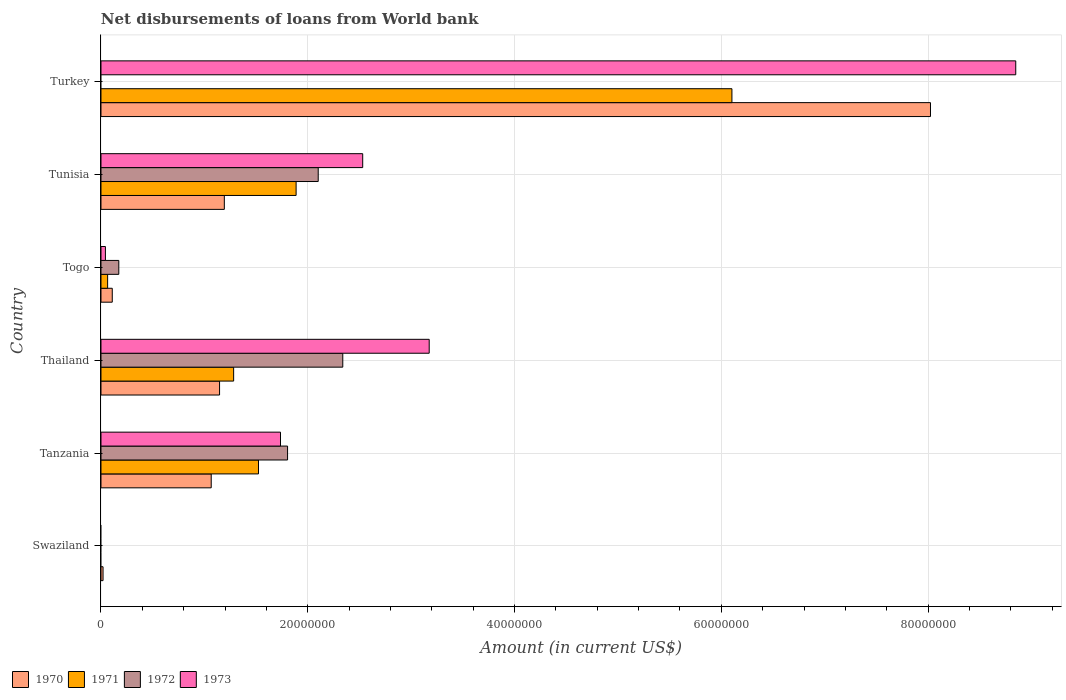Are the number of bars on each tick of the Y-axis equal?
Your response must be concise. No. What is the label of the 1st group of bars from the top?
Give a very brief answer. Turkey. In how many cases, is the number of bars for a given country not equal to the number of legend labels?
Keep it short and to the point. 2. What is the amount of loan disbursed from World Bank in 1973 in Tanzania?
Ensure brevity in your answer.  1.74e+07. Across all countries, what is the maximum amount of loan disbursed from World Bank in 1973?
Provide a succinct answer. 8.85e+07. What is the total amount of loan disbursed from World Bank in 1970 in the graph?
Provide a short and direct response. 1.16e+08. What is the difference between the amount of loan disbursed from World Bank in 1973 in Togo and that in Tunisia?
Make the answer very short. -2.49e+07. What is the difference between the amount of loan disbursed from World Bank in 1972 in Tunisia and the amount of loan disbursed from World Bank in 1970 in Tanzania?
Provide a succinct answer. 1.04e+07. What is the average amount of loan disbursed from World Bank in 1970 per country?
Your response must be concise. 1.93e+07. What is the difference between the amount of loan disbursed from World Bank in 1972 and amount of loan disbursed from World Bank in 1971 in Togo?
Offer a very short reply. 1.08e+06. What is the ratio of the amount of loan disbursed from World Bank in 1970 in Thailand to that in Togo?
Provide a short and direct response. 10.51. Is the amount of loan disbursed from World Bank in 1972 in Tanzania less than that in Thailand?
Give a very brief answer. Yes. What is the difference between the highest and the second highest amount of loan disbursed from World Bank in 1970?
Your answer should be compact. 6.83e+07. What is the difference between the highest and the lowest amount of loan disbursed from World Bank in 1972?
Ensure brevity in your answer.  2.34e+07. In how many countries, is the amount of loan disbursed from World Bank in 1973 greater than the average amount of loan disbursed from World Bank in 1973 taken over all countries?
Keep it short and to the point. 2. Is the sum of the amount of loan disbursed from World Bank in 1970 in Tanzania and Thailand greater than the maximum amount of loan disbursed from World Bank in 1972 across all countries?
Offer a terse response. No. Is it the case that in every country, the sum of the amount of loan disbursed from World Bank in 1972 and amount of loan disbursed from World Bank in 1973 is greater than the amount of loan disbursed from World Bank in 1970?
Make the answer very short. No. How many countries are there in the graph?
Offer a terse response. 6. Does the graph contain grids?
Your response must be concise. Yes. How are the legend labels stacked?
Your response must be concise. Horizontal. What is the title of the graph?
Your answer should be compact. Net disbursements of loans from World bank. Does "1976" appear as one of the legend labels in the graph?
Give a very brief answer. No. What is the Amount (in current US$) of 1970 in Swaziland?
Give a very brief answer. 1.99e+05. What is the Amount (in current US$) in 1972 in Swaziland?
Ensure brevity in your answer.  0. What is the Amount (in current US$) of 1970 in Tanzania?
Your answer should be compact. 1.07e+07. What is the Amount (in current US$) in 1971 in Tanzania?
Ensure brevity in your answer.  1.52e+07. What is the Amount (in current US$) in 1972 in Tanzania?
Offer a terse response. 1.80e+07. What is the Amount (in current US$) of 1973 in Tanzania?
Provide a short and direct response. 1.74e+07. What is the Amount (in current US$) of 1970 in Thailand?
Make the answer very short. 1.15e+07. What is the Amount (in current US$) of 1971 in Thailand?
Ensure brevity in your answer.  1.28e+07. What is the Amount (in current US$) of 1972 in Thailand?
Give a very brief answer. 2.34e+07. What is the Amount (in current US$) of 1973 in Thailand?
Your response must be concise. 3.17e+07. What is the Amount (in current US$) of 1970 in Togo?
Offer a terse response. 1.09e+06. What is the Amount (in current US$) in 1971 in Togo?
Your response must be concise. 6.42e+05. What is the Amount (in current US$) of 1972 in Togo?
Provide a succinct answer. 1.72e+06. What is the Amount (in current US$) in 1973 in Togo?
Your response must be concise. 4.29e+05. What is the Amount (in current US$) of 1970 in Tunisia?
Your answer should be compact. 1.19e+07. What is the Amount (in current US$) in 1971 in Tunisia?
Your answer should be compact. 1.89e+07. What is the Amount (in current US$) of 1972 in Tunisia?
Your response must be concise. 2.10e+07. What is the Amount (in current US$) in 1973 in Tunisia?
Offer a terse response. 2.53e+07. What is the Amount (in current US$) in 1970 in Turkey?
Your response must be concise. 8.02e+07. What is the Amount (in current US$) in 1971 in Turkey?
Offer a very short reply. 6.10e+07. What is the Amount (in current US$) of 1973 in Turkey?
Offer a very short reply. 8.85e+07. Across all countries, what is the maximum Amount (in current US$) in 1970?
Your answer should be compact. 8.02e+07. Across all countries, what is the maximum Amount (in current US$) in 1971?
Keep it short and to the point. 6.10e+07. Across all countries, what is the maximum Amount (in current US$) in 1972?
Provide a succinct answer. 2.34e+07. Across all countries, what is the maximum Amount (in current US$) of 1973?
Your response must be concise. 8.85e+07. Across all countries, what is the minimum Amount (in current US$) in 1970?
Keep it short and to the point. 1.99e+05. Across all countries, what is the minimum Amount (in current US$) of 1971?
Keep it short and to the point. 0. What is the total Amount (in current US$) of 1970 in the graph?
Your response must be concise. 1.16e+08. What is the total Amount (in current US$) in 1971 in the graph?
Provide a succinct answer. 1.09e+08. What is the total Amount (in current US$) of 1972 in the graph?
Ensure brevity in your answer.  6.42e+07. What is the total Amount (in current US$) in 1973 in the graph?
Provide a short and direct response. 1.63e+08. What is the difference between the Amount (in current US$) in 1970 in Swaziland and that in Tanzania?
Offer a very short reply. -1.05e+07. What is the difference between the Amount (in current US$) in 1970 in Swaziland and that in Thailand?
Give a very brief answer. -1.13e+07. What is the difference between the Amount (in current US$) of 1970 in Swaziland and that in Togo?
Ensure brevity in your answer.  -8.92e+05. What is the difference between the Amount (in current US$) in 1970 in Swaziland and that in Tunisia?
Give a very brief answer. -1.17e+07. What is the difference between the Amount (in current US$) of 1970 in Swaziland and that in Turkey?
Provide a short and direct response. -8.00e+07. What is the difference between the Amount (in current US$) in 1970 in Tanzania and that in Thailand?
Ensure brevity in your answer.  -8.08e+05. What is the difference between the Amount (in current US$) in 1971 in Tanzania and that in Thailand?
Your response must be concise. 2.40e+06. What is the difference between the Amount (in current US$) in 1972 in Tanzania and that in Thailand?
Provide a succinct answer. -5.34e+06. What is the difference between the Amount (in current US$) of 1973 in Tanzania and that in Thailand?
Ensure brevity in your answer.  -1.44e+07. What is the difference between the Amount (in current US$) in 1970 in Tanzania and that in Togo?
Your response must be concise. 9.57e+06. What is the difference between the Amount (in current US$) of 1971 in Tanzania and that in Togo?
Make the answer very short. 1.46e+07. What is the difference between the Amount (in current US$) of 1972 in Tanzania and that in Togo?
Offer a terse response. 1.63e+07. What is the difference between the Amount (in current US$) in 1973 in Tanzania and that in Togo?
Your answer should be compact. 1.69e+07. What is the difference between the Amount (in current US$) in 1970 in Tanzania and that in Tunisia?
Provide a succinct answer. -1.27e+06. What is the difference between the Amount (in current US$) of 1971 in Tanzania and that in Tunisia?
Your answer should be compact. -3.64e+06. What is the difference between the Amount (in current US$) of 1972 in Tanzania and that in Tunisia?
Ensure brevity in your answer.  -2.96e+06. What is the difference between the Amount (in current US$) of 1973 in Tanzania and that in Tunisia?
Provide a short and direct response. -7.95e+06. What is the difference between the Amount (in current US$) of 1970 in Tanzania and that in Turkey?
Ensure brevity in your answer.  -6.96e+07. What is the difference between the Amount (in current US$) of 1971 in Tanzania and that in Turkey?
Provide a short and direct response. -4.58e+07. What is the difference between the Amount (in current US$) in 1973 in Tanzania and that in Turkey?
Your response must be concise. -7.11e+07. What is the difference between the Amount (in current US$) in 1970 in Thailand and that in Togo?
Your response must be concise. 1.04e+07. What is the difference between the Amount (in current US$) of 1971 in Thailand and that in Togo?
Provide a succinct answer. 1.22e+07. What is the difference between the Amount (in current US$) of 1972 in Thailand and that in Togo?
Offer a terse response. 2.17e+07. What is the difference between the Amount (in current US$) of 1973 in Thailand and that in Togo?
Offer a terse response. 3.13e+07. What is the difference between the Amount (in current US$) of 1970 in Thailand and that in Tunisia?
Provide a short and direct response. -4.60e+05. What is the difference between the Amount (in current US$) of 1971 in Thailand and that in Tunisia?
Keep it short and to the point. -6.04e+06. What is the difference between the Amount (in current US$) of 1972 in Thailand and that in Tunisia?
Your response must be concise. 2.38e+06. What is the difference between the Amount (in current US$) in 1973 in Thailand and that in Tunisia?
Offer a terse response. 6.43e+06. What is the difference between the Amount (in current US$) in 1970 in Thailand and that in Turkey?
Make the answer very short. -6.88e+07. What is the difference between the Amount (in current US$) of 1971 in Thailand and that in Turkey?
Ensure brevity in your answer.  -4.82e+07. What is the difference between the Amount (in current US$) in 1973 in Thailand and that in Turkey?
Your response must be concise. -5.67e+07. What is the difference between the Amount (in current US$) in 1970 in Togo and that in Tunisia?
Make the answer very short. -1.08e+07. What is the difference between the Amount (in current US$) in 1971 in Togo and that in Tunisia?
Make the answer very short. -1.82e+07. What is the difference between the Amount (in current US$) of 1972 in Togo and that in Tunisia?
Your answer should be compact. -1.93e+07. What is the difference between the Amount (in current US$) in 1973 in Togo and that in Tunisia?
Offer a terse response. -2.49e+07. What is the difference between the Amount (in current US$) in 1970 in Togo and that in Turkey?
Provide a succinct answer. -7.91e+07. What is the difference between the Amount (in current US$) of 1971 in Togo and that in Turkey?
Offer a terse response. -6.04e+07. What is the difference between the Amount (in current US$) of 1973 in Togo and that in Turkey?
Offer a terse response. -8.80e+07. What is the difference between the Amount (in current US$) in 1970 in Tunisia and that in Turkey?
Your answer should be compact. -6.83e+07. What is the difference between the Amount (in current US$) in 1971 in Tunisia and that in Turkey?
Your response must be concise. -4.22e+07. What is the difference between the Amount (in current US$) of 1973 in Tunisia and that in Turkey?
Your answer should be compact. -6.32e+07. What is the difference between the Amount (in current US$) of 1970 in Swaziland and the Amount (in current US$) of 1971 in Tanzania?
Offer a terse response. -1.50e+07. What is the difference between the Amount (in current US$) of 1970 in Swaziland and the Amount (in current US$) of 1972 in Tanzania?
Keep it short and to the point. -1.78e+07. What is the difference between the Amount (in current US$) of 1970 in Swaziland and the Amount (in current US$) of 1973 in Tanzania?
Provide a succinct answer. -1.72e+07. What is the difference between the Amount (in current US$) in 1970 in Swaziland and the Amount (in current US$) in 1971 in Thailand?
Keep it short and to the point. -1.26e+07. What is the difference between the Amount (in current US$) in 1970 in Swaziland and the Amount (in current US$) in 1972 in Thailand?
Make the answer very short. -2.32e+07. What is the difference between the Amount (in current US$) in 1970 in Swaziland and the Amount (in current US$) in 1973 in Thailand?
Provide a succinct answer. -3.15e+07. What is the difference between the Amount (in current US$) of 1970 in Swaziland and the Amount (in current US$) of 1971 in Togo?
Offer a terse response. -4.43e+05. What is the difference between the Amount (in current US$) in 1970 in Swaziland and the Amount (in current US$) in 1972 in Togo?
Provide a short and direct response. -1.52e+06. What is the difference between the Amount (in current US$) in 1970 in Swaziland and the Amount (in current US$) in 1973 in Togo?
Your answer should be compact. -2.30e+05. What is the difference between the Amount (in current US$) of 1970 in Swaziland and the Amount (in current US$) of 1971 in Tunisia?
Offer a very short reply. -1.87e+07. What is the difference between the Amount (in current US$) of 1970 in Swaziland and the Amount (in current US$) of 1972 in Tunisia?
Make the answer very short. -2.08e+07. What is the difference between the Amount (in current US$) in 1970 in Swaziland and the Amount (in current US$) in 1973 in Tunisia?
Your response must be concise. -2.51e+07. What is the difference between the Amount (in current US$) in 1970 in Swaziland and the Amount (in current US$) in 1971 in Turkey?
Your answer should be compact. -6.08e+07. What is the difference between the Amount (in current US$) of 1970 in Swaziland and the Amount (in current US$) of 1973 in Turkey?
Keep it short and to the point. -8.83e+07. What is the difference between the Amount (in current US$) of 1970 in Tanzania and the Amount (in current US$) of 1971 in Thailand?
Ensure brevity in your answer.  -2.17e+06. What is the difference between the Amount (in current US$) in 1970 in Tanzania and the Amount (in current US$) in 1972 in Thailand?
Offer a terse response. -1.27e+07. What is the difference between the Amount (in current US$) of 1970 in Tanzania and the Amount (in current US$) of 1973 in Thailand?
Provide a short and direct response. -2.11e+07. What is the difference between the Amount (in current US$) of 1971 in Tanzania and the Amount (in current US$) of 1972 in Thailand?
Make the answer very short. -8.15e+06. What is the difference between the Amount (in current US$) of 1971 in Tanzania and the Amount (in current US$) of 1973 in Thailand?
Provide a succinct answer. -1.65e+07. What is the difference between the Amount (in current US$) in 1972 in Tanzania and the Amount (in current US$) in 1973 in Thailand?
Make the answer very short. -1.37e+07. What is the difference between the Amount (in current US$) in 1970 in Tanzania and the Amount (in current US$) in 1971 in Togo?
Provide a short and direct response. 1.00e+07. What is the difference between the Amount (in current US$) in 1970 in Tanzania and the Amount (in current US$) in 1972 in Togo?
Offer a terse response. 8.94e+06. What is the difference between the Amount (in current US$) in 1970 in Tanzania and the Amount (in current US$) in 1973 in Togo?
Your response must be concise. 1.02e+07. What is the difference between the Amount (in current US$) of 1971 in Tanzania and the Amount (in current US$) of 1972 in Togo?
Your answer should be compact. 1.35e+07. What is the difference between the Amount (in current US$) of 1971 in Tanzania and the Amount (in current US$) of 1973 in Togo?
Provide a short and direct response. 1.48e+07. What is the difference between the Amount (in current US$) of 1972 in Tanzania and the Amount (in current US$) of 1973 in Togo?
Provide a succinct answer. 1.76e+07. What is the difference between the Amount (in current US$) in 1970 in Tanzania and the Amount (in current US$) in 1971 in Tunisia?
Offer a terse response. -8.21e+06. What is the difference between the Amount (in current US$) in 1970 in Tanzania and the Amount (in current US$) in 1972 in Tunisia?
Keep it short and to the point. -1.04e+07. What is the difference between the Amount (in current US$) of 1970 in Tanzania and the Amount (in current US$) of 1973 in Tunisia?
Your answer should be very brief. -1.47e+07. What is the difference between the Amount (in current US$) in 1971 in Tanzania and the Amount (in current US$) in 1972 in Tunisia?
Your answer should be very brief. -5.78e+06. What is the difference between the Amount (in current US$) of 1971 in Tanzania and the Amount (in current US$) of 1973 in Tunisia?
Provide a succinct answer. -1.01e+07. What is the difference between the Amount (in current US$) in 1972 in Tanzania and the Amount (in current US$) in 1973 in Tunisia?
Provide a short and direct response. -7.27e+06. What is the difference between the Amount (in current US$) of 1970 in Tanzania and the Amount (in current US$) of 1971 in Turkey?
Make the answer very short. -5.04e+07. What is the difference between the Amount (in current US$) in 1970 in Tanzania and the Amount (in current US$) in 1973 in Turkey?
Your answer should be compact. -7.78e+07. What is the difference between the Amount (in current US$) of 1971 in Tanzania and the Amount (in current US$) of 1973 in Turkey?
Offer a very short reply. -7.32e+07. What is the difference between the Amount (in current US$) of 1972 in Tanzania and the Amount (in current US$) of 1973 in Turkey?
Give a very brief answer. -7.04e+07. What is the difference between the Amount (in current US$) in 1970 in Thailand and the Amount (in current US$) in 1971 in Togo?
Your response must be concise. 1.08e+07. What is the difference between the Amount (in current US$) of 1970 in Thailand and the Amount (in current US$) of 1972 in Togo?
Keep it short and to the point. 9.75e+06. What is the difference between the Amount (in current US$) in 1970 in Thailand and the Amount (in current US$) in 1973 in Togo?
Provide a succinct answer. 1.10e+07. What is the difference between the Amount (in current US$) of 1971 in Thailand and the Amount (in current US$) of 1972 in Togo?
Ensure brevity in your answer.  1.11e+07. What is the difference between the Amount (in current US$) of 1971 in Thailand and the Amount (in current US$) of 1973 in Togo?
Make the answer very short. 1.24e+07. What is the difference between the Amount (in current US$) of 1972 in Thailand and the Amount (in current US$) of 1973 in Togo?
Provide a short and direct response. 2.30e+07. What is the difference between the Amount (in current US$) in 1970 in Thailand and the Amount (in current US$) in 1971 in Tunisia?
Your answer should be compact. -7.40e+06. What is the difference between the Amount (in current US$) in 1970 in Thailand and the Amount (in current US$) in 1972 in Tunisia?
Ensure brevity in your answer.  -9.54e+06. What is the difference between the Amount (in current US$) in 1970 in Thailand and the Amount (in current US$) in 1973 in Tunisia?
Ensure brevity in your answer.  -1.38e+07. What is the difference between the Amount (in current US$) of 1971 in Thailand and the Amount (in current US$) of 1972 in Tunisia?
Keep it short and to the point. -8.18e+06. What is the difference between the Amount (in current US$) in 1971 in Thailand and the Amount (in current US$) in 1973 in Tunisia?
Offer a terse response. -1.25e+07. What is the difference between the Amount (in current US$) in 1972 in Thailand and the Amount (in current US$) in 1973 in Tunisia?
Provide a succinct answer. -1.93e+06. What is the difference between the Amount (in current US$) of 1970 in Thailand and the Amount (in current US$) of 1971 in Turkey?
Provide a succinct answer. -4.96e+07. What is the difference between the Amount (in current US$) in 1970 in Thailand and the Amount (in current US$) in 1973 in Turkey?
Offer a very short reply. -7.70e+07. What is the difference between the Amount (in current US$) in 1971 in Thailand and the Amount (in current US$) in 1973 in Turkey?
Your answer should be very brief. -7.56e+07. What is the difference between the Amount (in current US$) in 1972 in Thailand and the Amount (in current US$) in 1973 in Turkey?
Ensure brevity in your answer.  -6.51e+07. What is the difference between the Amount (in current US$) in 1970 in Togo and the Amount (in current US$) in 1971 in Tunisia?
Your answer should be compact. -1.78e+07. What is the difference between the Amount (in current US$) in 1970 in Togo and the Amount (in current US$) in 1972 in Tunisia?
Your answer should be compact. -1.99e+07. What is the difference between the Amount (in current US$) in 1970 in Togo and the Amount (in current US$) in 1973 in Tunisia?
Your response must be concise. -2.42e+07. What is the difference between the Amount (in current US$) of 1971 in Togo and the Amount (in current US$) of 1972 in Tunisia?
Provide a short and direct response. -2.04e+07. What is the difference between the Amount (in current US$) of 1971 in Togo and the Amount (in current US$) of 1973 in Tunisia?
Your answer should be compact. -2.47e+07. What is the difference between the Amount (in current US$) of 1972 in Togo and the Amount (in current US$) of 1973 in Tunisia?
Provide a succinct answer. -2.36e+07. What is the difference between the Amount (in current US$) of 1970 in Togo and the Amount (in current US$) of 1971 in Turkey?
Your answer should be compact. -5.99e+07. What is the difference between the Amount (in current US$) in 1970 in Togo and the Amount (in current US$) in 1973 in Turkey?
Make the answer very short. -8.74e+07. What is the difference between the Amount (in current US$) of 1971 in Togo and the Amount (in current US$) of 1973 in Turkey?
Ensure brevity in your answer.  -8.78e+07. What is the difference between the Amount (in current US$) of 1972 in Togo and the Amount (in current US$) of 1973 in Turkey?
Keep it short and to the point. -8.68e+07. What is the difference between the Amount (in current US$) of 1970 in Tunisia and the Amount (in current US$) of 1971 in Turkey?
Make the answer very short. -4.91e+07. What is the difference between the Amount (in current US$) of 1970 in Tunisia and the Amount (in current US$) of 1973 in Turkey?
Make the answer very short. -7.65e+07. What is the difference between the Amount (in current US$) in 1971 in Tunisia and the Amount (in current US$) in 1973 in Turkey?
Make the answer very short. -6.96e+07. What is the difference between the Amount (in current US$) in 1972 in Tunisia and the Amount (in current US$) in 1973 in Turkey?
Your answer should be very brief. -6.75e+07. What is the average Amount (in current US$) in 1970 per country?
Keep it short and to the point. 1.93e+07. What is the average Amount (in current US$) of 1971 per country?
Provide a short and direct response. 1.81e+07. What is the average Amount (in current US$) of 1972 per country?
Ensure brevity in your answer.  1.07e+07. What is the average Amount (in current US$) of 1973 per country?
Keep it short and to the point. 2.72e+07. What is the difference between the Amount (in current US$) in 1970 and Amount (in current US$) in 1971 in Tanzania?
Make the answer very short. -4.57e+06. What is the difference between the Amount (in current US$) of 1970 and Amount (in current US$) of 1972 in Tanzania?
Give a very brief answer. -7.38e+06. What is the difference between the Amount (in current US$) in 1970 and Amount (in current US$) in 1973 in Tanzania?
Keep it short and to the point. -6.70e+06. What is the difference between the Amount (in current US$) of 1971 and Amount (in current US$) of 1972 in Tanzania?
Offer a terse response. -2.81e+06. What is the difference between the Amount (in current US$) of 1971 and Amount (in current US$) of 1973 in Tanzania?
Your answer should be compact. -2.13e+06. What is the difference between the Amount (in current US$) of 1972 and Amount (in current US$) of 1973 in Tanzania?
Make the answer very short. 6.84e+05. What is the difference between the Amount (in current US$) in 1970 and Amount (in current US$) in 1971 in Thailand?
Your answer should be very brief. -1.36e+06. What is the difference between the Amount (in current US$) in 1970 and Amount (in current US$) in 1972 in Thailand?
Make the answer very short. -1.19e+07. What is the difference between the Amount (in current US$) of 1970 and Amount (in current US$) of 1973 in Thailand?
Make the answer very short. -2.03e+07. What is the difference between the Amount (in current US$) in 1971 and Amount (in current US$) in 1972 in Thailand?
Offer a terse response. -1.06e+07. What is the difference between the Amount (in current US$) of 1971 and Amount (in current US$) of 1973 in Thailand?
Provide a short and direct response. -1.89e+07. What is the difference between the Amount (in current US$) of 1972 and Amount (in current US$) of 1973 in Thailand?
Your response must be concise. -8.36e+06. What is the difference between the Amount (in current US$) of 1970 and Amount (in current US$) of 1971 in Togo?
Your response must be concise. 4.49e+05. What is the difference between the Amount (in current US$) in 1970 and Amount (in current US$) in 1972 in Togo?
Provide a short and direct response. -6.31e+05. What is the difference between the Amount (in current US$) in 1970 and Amount (in current US$) in 1973 in Togo?
Offer a very short reply. 6.62e+05. What is the difference between the Amount (in current US$) of 1971 and Amount (in current US$) of 1972 in Togo?
Make the answer very short. -1.08e+06. What is the difference between the Amount (in current US$) in 1971 and Amount (in current US$) in 1973 in Togo?
Your answer should be compact. 2.13e+05. What is the difference between the Amount (in current US$) in 1972 and Amount (in current US$) in 1973 in Togo?
Give a very brief answer. 1.29e+06. What is the difference between the Amount (in current US$) of 1970 and Amount (in current US$) of 1971 in Tunisia?
Provide a succinct answer. -6.94e+06. What is the difference between the Amount (in current US$) in 1970 and Amount (in current US$) in 1972 in Tunisia?
Your answer should be very brief. -9.08e+06. What is the difference between the Amount (in current US$) in 1970 and Amount (in current US$) in 1973 in Tunisia?
Offer a very short reply. -1.34e+07. What is the difference between the Amount (in current US$) of 1971 and Amount (in current US$) of 1972 in Tunisia?
Offer a terse response. -2.14e+06. What is the difference between the Amount (in current US$) of 1971 and Amount (in current US$) of 1973 in Tunisia?
Your answer should be compact. -6.44e+06. What is the difference between the Amount (in current US$) of 1972 and Amount (in current US$) of 1973 in Tunisia?
Your answer should be very brief. -4.30e+06. What is the difference between the Amount (in current US$) in 1970 and Amount (in current US$) in 1971 in Turkey?
Provide a short and direct response. 1.92e+07. What is the difference between the Amount (in current US$) of 1970 and Amount (in current US$) of 1973 in Turkey?
Offer a terse response. -8.25e+06. What is the difference between the Amount (in current US$) of 1971 and Amount (in current US$) of 1973 in Turkey?
Ensure brevity in your answer.  -2.75e+07. What is the ratio of the Amount (in current US$) in 1970 in Swaziland to that in Tanzania?
Your response must be concise. 0.02. What is the ratio of the Amount (in current US$) of 1970 in Swaziland to that in Thailand?
Keep it short and to the point. 0.02. What is the ratio of the Amount (in current US$) in 1970 in Swaziland to that in Togo?
Offer a terse response. 0.18. What is the ratio of the Amount (in current US$) of 1970 in Swaziland to that in Tunisia?
Offer a very short reply. 0.02. What is the ratio of the Amount (in current US$) in 1970 in Swaziland to that in Turkey?
Provide a succinct answer. 0. What is the ratio of the Amount (in current US$) of 1970 in Tanzania to that in Thailand?
Provide a short and direct response. 0.93. What is the ratio of the Amount (in current US$) of 1971 in Tanzania to that in Thailand?
Ensure brevity in your answer.  1.19. What is the ratio of the Amount (in current US$) of 1972 in Tanzania to that in Thailand?
Keep it short and to the point. 0.77. What is the ratio of the Amount (in current US$) of 1973 in Tanzania to that in Thailand?
Your answer should be compact. 0.55. What is the ratio of the Amount (in current US$) of 1970 in Tanzania to that in Togo?
Provide a succinct answer. 9.77. What is the ratio of the Amount (in current US$) of 1971 in Tanzania to that in Togo?
Provide a succinct answer. 23.73. What is the ratio of the Amount (in current US$) in 1972 in Tanzania to that in Togo?
Your answer should be very brief. 10.48. What is the ratio of the Amount (in current US$) of 1973 in Tanzania to that in Togo?
Give a very brief answer. 40.47. What is the ratio of the Amount (in current US$) of 1970 in Tanzania to that in Tunisia?
Offer a terse response. 0.89. What is the ratio of the Amount (in current US$) of 1971 in Tanzania to that in Tunisia?
Keep it short and to the point. 0.81. What is the ratio of the Amount (in current US$) of 1972 in Tanzania to that in Tunisia?
Your answer should be very brief. 0.86. What is the ratio of the Amount (in current US$) in 1973 in Tanzania to that in Tunisia?
Give a very brief answer. 0.69. What is the ratio of the Amount (in current US$) of 1970 in Tanzania to that in Turkey?
Offer a very short reply. 0.13. What is the ratio of the Amount (in current US$) of 1971 in Tanzania to that in Turkey?
Keep it short and to the point. 0.25. What is the ratio of the Amount (in current US$) of 1973 in Tanzania to that in Turkey?
Provide a succinct answer. 0.2. What is the ratio of the Amount (in current US$) of 1970 in Thailand to that in Togo?
Provide a succinct answer. 10.51. What is the ratio of the Amount (in current US$) in 1971 in Thailand to that in Togo?
Provide a short and direct response. 19.98. What is the ratio of the Amount (in current US$) of 1972 in Thailand to that in Togo?
Provide a short and direct response. 13.58. What is the ratio of the Amount (in current US$) in 1973 in Thailand to that in Togo?
Offer a terse response. 74. What is the ratio of the Amount (in current US$) in 1970 in Thailand to that in Tunisia?
Ensure brevity in your answer.  0.96. What is the ratio of the Amount (in current US$) in 1971 in Thailand to that in Tunisia?
Make the answer very short. 0.68. What is the ratio of the Amount (in current US$) of 1972 in Thailand to that in Tunisia?
Provide a short and direct response. 1.11. What is the ratio of the Amount (in current US$) of 1973 in Thailand to that in Tunisia?
Provide a short and direct response. 1.25. What is the ratio of the Amount (in current US$) in 1970 in Thailand to that in Turkey?
Ensure brevity in your answer.  0.14. What is the ratio of the Amount (in current US$) in 1971 in Thailand to that in Turkey?
Ensure brevity in your answer.  0.21. What is the ratio of the Amount (in current US$) in 1973 in Thailand to that in Turkey?
Offer a terse response. 0.36. What is the ratio of the Amount (in current US$) in 1970 in Togo to that in Tunisia?
Your response must be concise. 0.09. What is the ratio of the Amount (in current US$) of 1971 in Togo to that in Tunisia?
Ensure brevity in your answer.  0.03. What is the ratio of the Amount (in current US$) in 1972 in Togo to that in Tunisia?
Give a very brief answer. 0.08. What is the ratio of the Amount (in current US$) in 1973 in Togo to that in Tunisia?
Keep it short and to the point. 0.02. What is the ratio of the Amount (in current US$) in 1970 in Togo to that in Turkey?
Make the answer very short. 0.01. What is the ratio of the Amount (in current US$) in 1971 in Togo to that in Turkey?
Provide a succinct answer. 0.01. What is the ratio of the Amount (in current US$) in 1973 in Togo to that in Turkey?
Keep it short and to the point. 0. What is the ratio of the Amount (in current US$) of 1970 in Tunisia to that in Turkey?
Ensure brevity in your answer.  0.15. What is the ratio of the Amount (in current US$) of 1971 in Tunisia to that in Turkey?
Your answer should be very brief. 0.31. What is the ratio of the Amount (in current US$) of 1973 in Tunisia to that in Turkey?
Ensure brevity in your answer.  0.29. What is the difference between the highest and the second highest Amount (in current US$) in 1970?
Provide a succinct answer. 6.83e+07. What is the difference between the highest and the second highest Amount (in current US$) of 1971?
Give a very brief answer. 4.22e+07. What is the difference between the highest and the second highest Amount (in current US$) of 1972?
Provide a succinct answer. 2.38e+06. What is the difference between the highest and the second highest Amount (in current US$) in 1973?
Your answer should be very brief. 5.67e+07. What is the difference between the highest and the lowest Amount (in current US$) of 1970?
Offer a terse response. 8.00e+07. What is the difference between the highest and the lowest Amount (in current US$) in 1971?
Your answer should be very brief. 6.10e+07. What is the difference between the highest and the lowest Amount (in current US$) in 1972?
Provide a short and direct response. 2.34e+07. What is the difference between the highest and the lowest Amount (in current US$) of 1973?
Your answer should be very brief. 8.85e+07. 